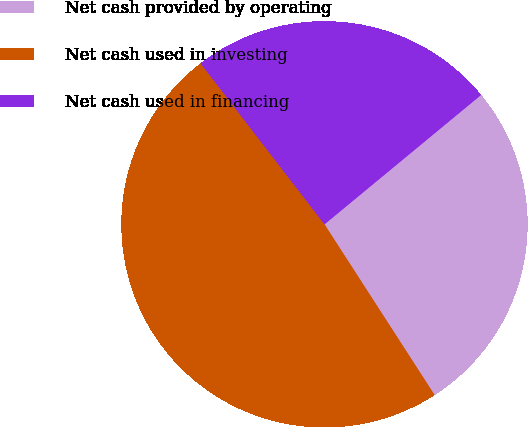<chart> <loc_0><loc_0><loc_500><loc_500><pie_chart><fcel>Net cash provided by operating<fcel>Net cash used in investing<fcel>Net cash used in financing<nl><fcel>26.87%<fcel>48.68%<fcel>24.45%<nl></chart> 